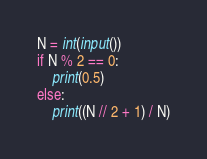<code> <loc_0><loc_0><loc_500><loc_500><_Python_>N = int(input())
if N % 2 == 0:
    print(0.5)
else:
    print((N // 2 + 1) / N)</code> 